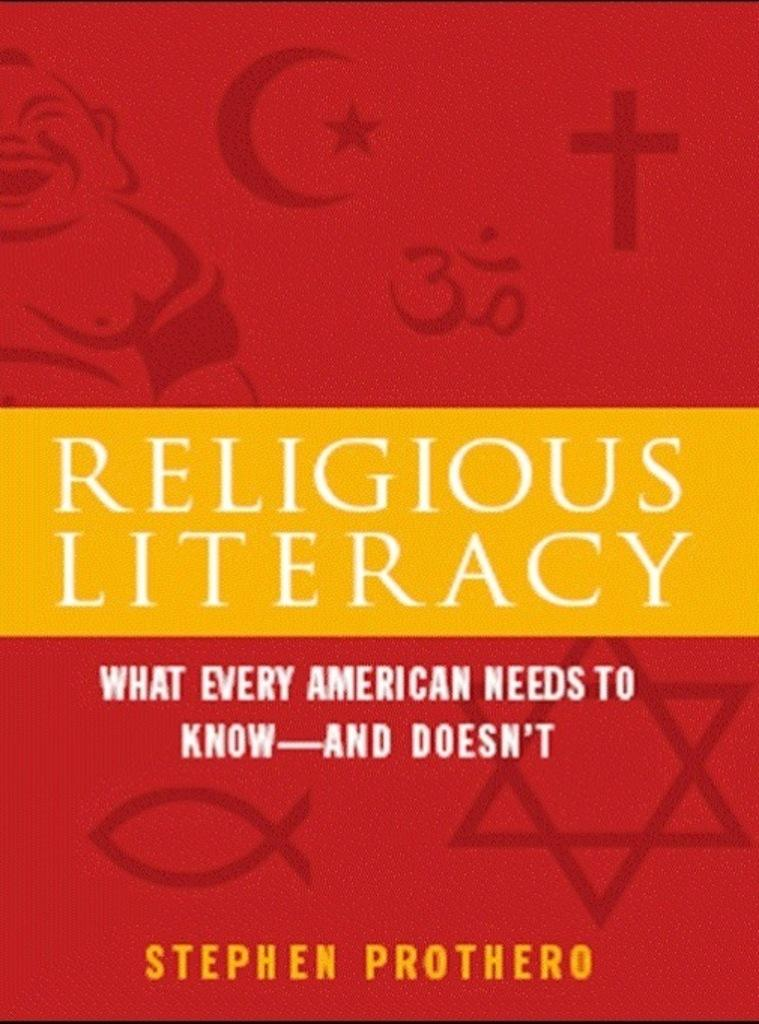<image>
Offer a succinct explanation of the picture presented. a book with the name of religious literacy 